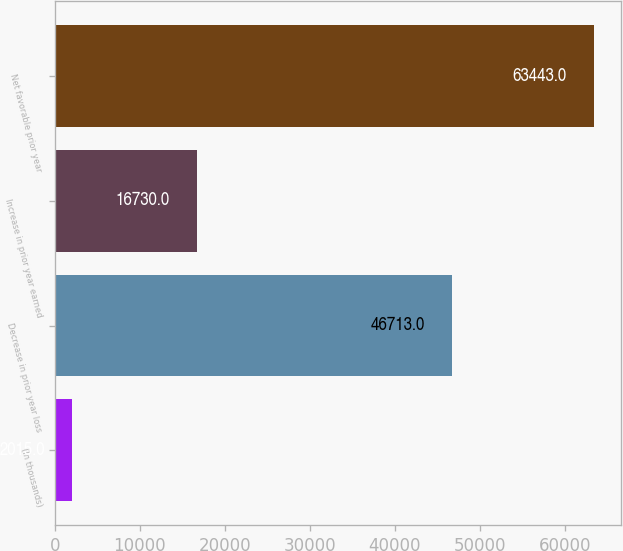Convert chart to OTSL. <chart><loc_0><loc_0><loc_500><loc_500><bar_chart><fcel>(In thousands)<fcel>Decrease in prior year loss<fcel>Increase in prior year earned<fcel>Net favorable prior year<nl><fcel>2015<fcel>46713<fcel>16730<fcel>63443<nl></chart> 